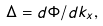Convert formula to latex. <formula><loc_0><loc_0><loc_500><loc_500>\Delta = { d \Phi } / { d k _ { x } } ,</formula> 